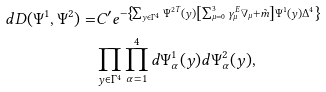<formula> <loc_0><loc_0><loc_500><loc_500>d D ( \Psi ^ { 1 } , \Psi ^ { 2 } ) = & C ^ { \prime } e ^ { - \left \{ \sum _ { y \in \Gamma ^ { 4 } } \Psi ^ { 2 T } ( y ) \left [ \sum _ { \mu = 0 } ^ { 3 } \gamma ^ { E } _ { \mu } \nabla _ { \mu } + \tilde { m } \right ] \Psi ^ { 1 } ( y ) \Delta ^ { 4 } \right \} } \\ & \prod _ { y \in \Gamma ^ { 4 } } \prod _ { \alpha = 1 } ^ { 4 } d \Psi ^ { 1 } _ { \alpha } ( y ) d \Psi ^ { 2 } _ { \alpha } ( y ) ,</formula> 